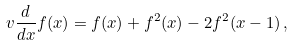Convert formula to latex. <formula><loc_0><loc_0><loc_500><loc_500>v \frac { d } { d x } f ( x ) = f ( x ) + f ^ { 2 } ( x ) - 2 f ^ { 2 } ( x - 1 ) \, ,</formula> 